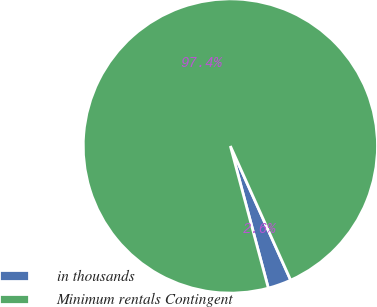Convert chart. <chart><loc_0><loc_0><loc_500><loc_500><pie_chart><fcel>in thousands<fcel>Minimum rentals Contingent<nl><fcel>2.57%<fcel>97.43%<nl></chart> 